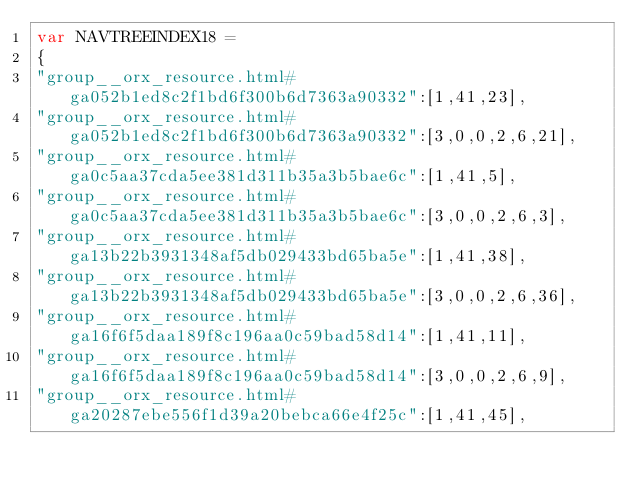Convert code to text. <code><loc_0><loc_0><loc_500><loc_500><_JavaScript_>var NAVTREEINDEX18 =
{
"group__orx_resource.html#ga052b1ed8c2f1bd6f300b6d7363a90332":[1,41,23],
"group__orx_resource.html#ga052b1ed8c2f1bd6f300b6d7363a90332":[3,0,0,2,6,21],
"group__orx_resource.html#ga0c5aa37cda5ee381d311b35a3b5bae6c":[1,41,5],
"group__orx_resource.html#ga0c5aa37cda5ee381d311b35a3b5bae6c":[3,0,0,2,6,3],
"group__orx_resource.html#ga13b22b3931348af5db029433bd65ba5e":[1,41,38],
"group__orx_resource.html#ga13b22b3931348af5db029433bd65ba5e":[3,0,0,2,6,36],
"group__orx_resource.html#ga16f6f5daa189f8c196aa0c59bad58d14":[1,41,11],
"group__orx_resource.html#ga16f6f5daa189f8c196aa0c59bad58d14":[3,0,0,2,6,9],
"group__orx_resource.html#ga20287ebe556f1d39a20bebca66e4f25c":[1,41,45],</code> 